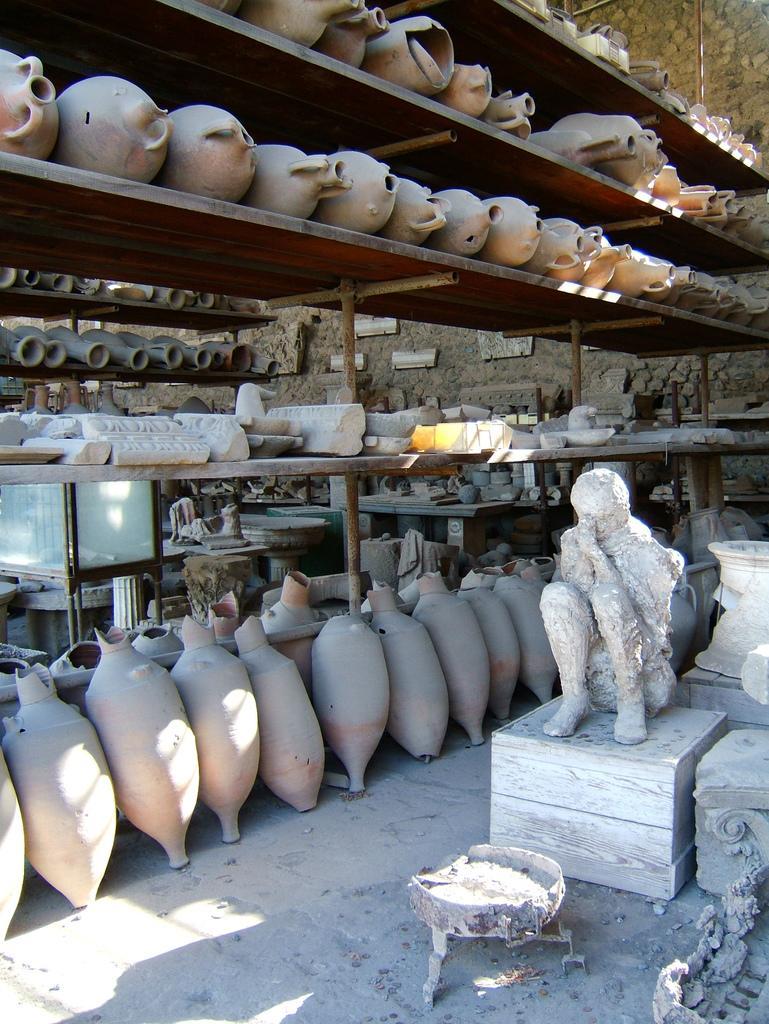How would you summarize this image in a sentence or two? In this image there are multiple pots are kept in some shelves and there is a statue at bottom of this image and there is one object at bottom right side of this image and there is wall in the background. 